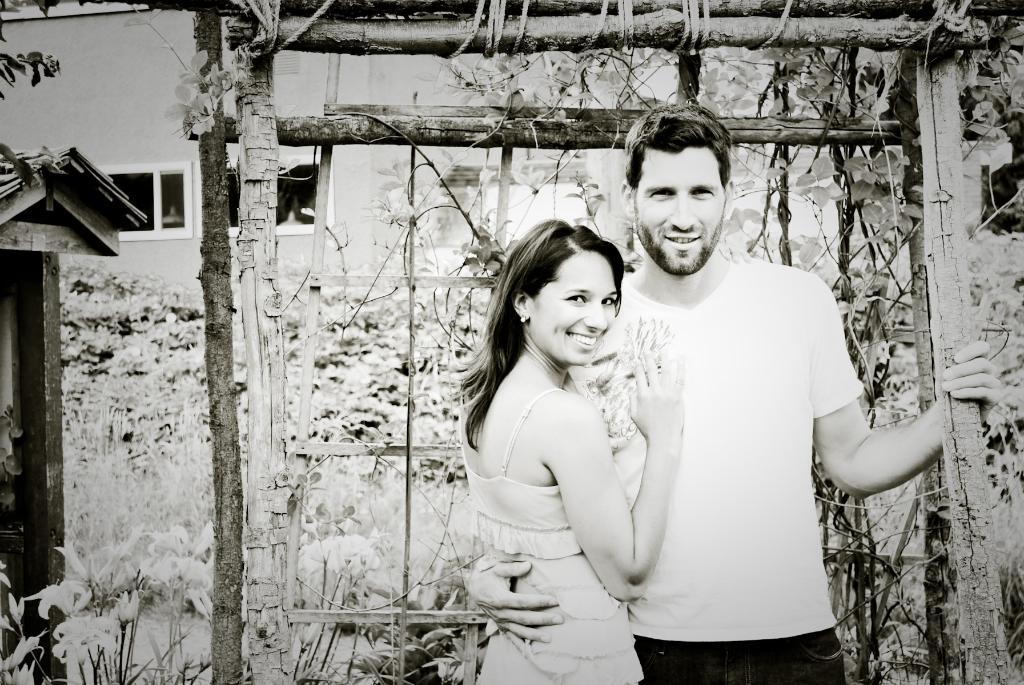Who can be seen in the image? There is a man and a lady in the image. What expressions do the man and the lady have? Both the man and the lady are smiling. What can be seen in the background of the image? There is a wood, trees, and buildings in the background of the image. What time of day is the event taking place in the image? There is no specific event mentioned in the image, and the time of day cannot be determined from the image alone. 